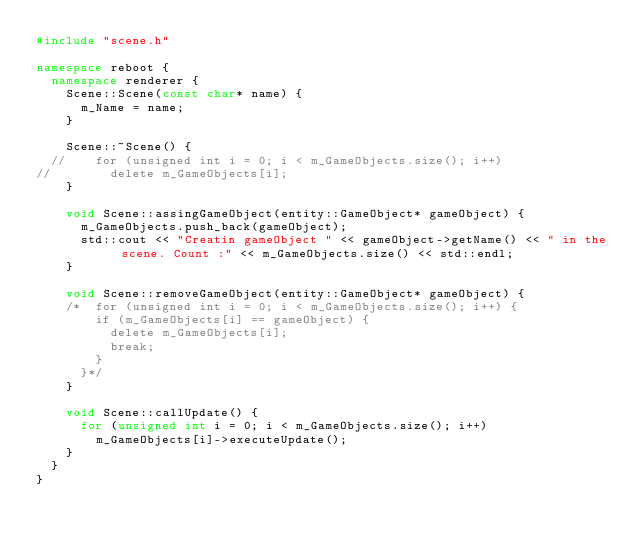<code> <loc_0><loc_0><loc_500><loc_500><_C++_>#include "scene.h"

namespace reboot {
	namespace renderer {
		Scene::Scene(const char* name) {
			m_Name = name;
		}
		
		Scene::~Scene() {
	//		for (unsigned int i = 0; i < m_GameObjects.size(); i++)
//				delete m_GameObjects[i];
		}

		void Scene::assingGameObject(entity::GameObject* gameObject) {
			m_GameObjects.push_back(gameObject);
			std::cout << "Creatin gameObject " << gameObject->getName() << " in the scene. Count :" << m_GameObjects.size() << std::endl;
		}

		void Scene::removeGameObject(entity::GameObject* gameObject) {
		/*	for (unsigned int i = 0; i < m_GameObjects.size(); i++) {
				if (m_GameObjects[i] == gameObject) {
					delete m_GameObjects[i];
					break;
				}
			}*/
		}

		void Scene::callUpdate() {
			for (unsigned int i = 0; i < m_GameObjects.size(); i++)
				m_GameObjects[i]->executeUpdate();
		}
	}
}</code> 